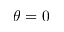Convert formula to latex. <formula><loc_0><loc_0><loc_500><loc_500>\theta = 0</formula> 